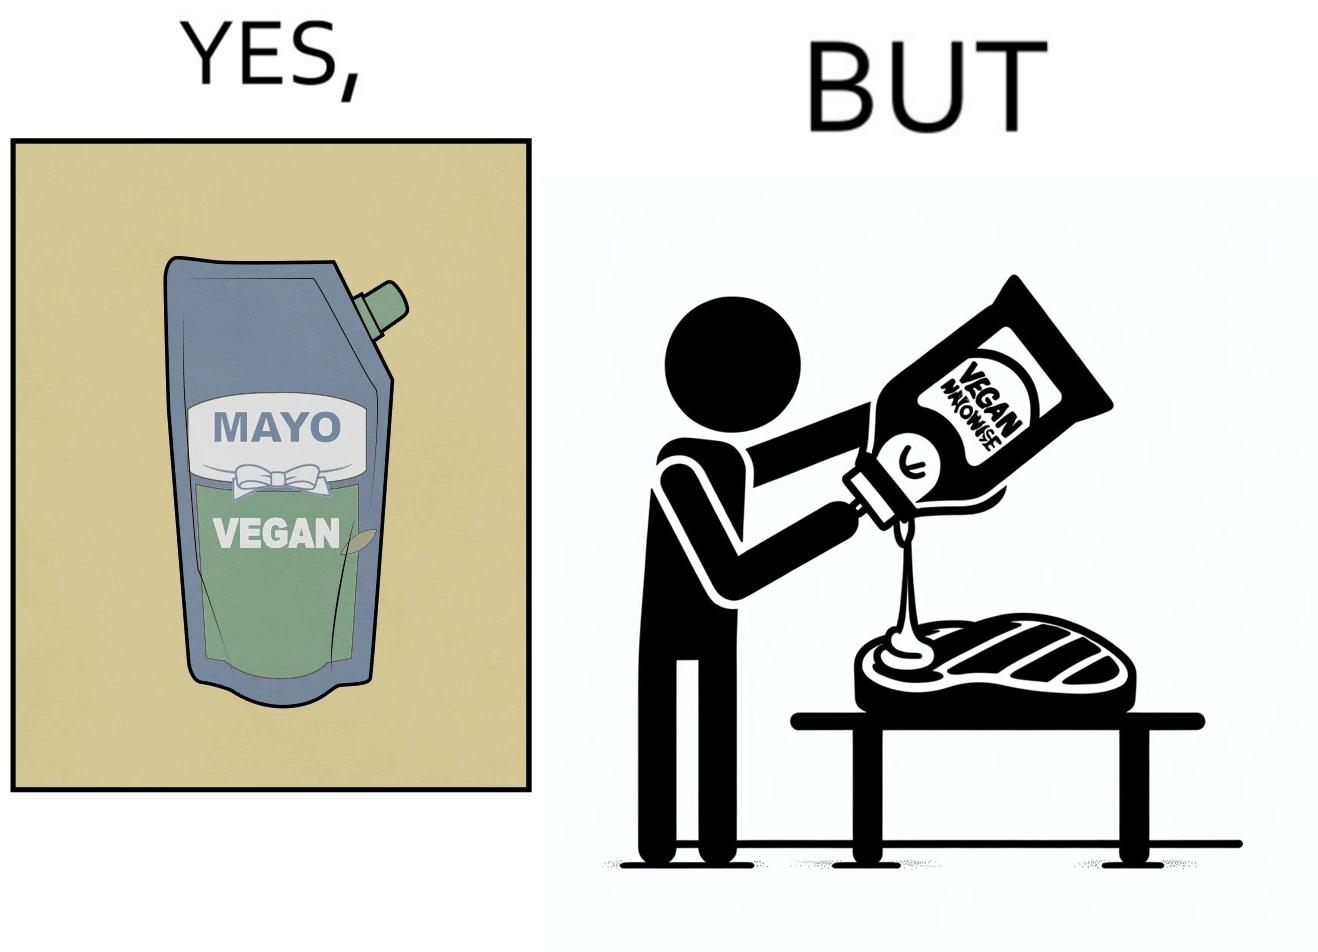Would you classify this image as satirical? Yes, this image is satirical. 